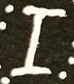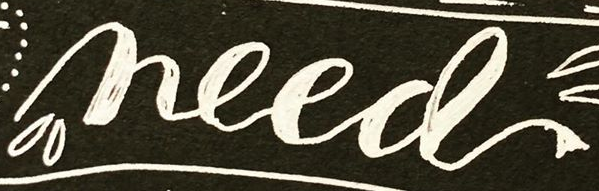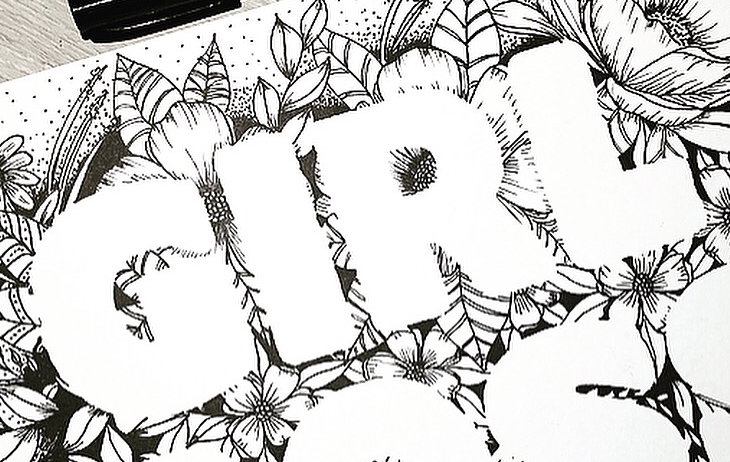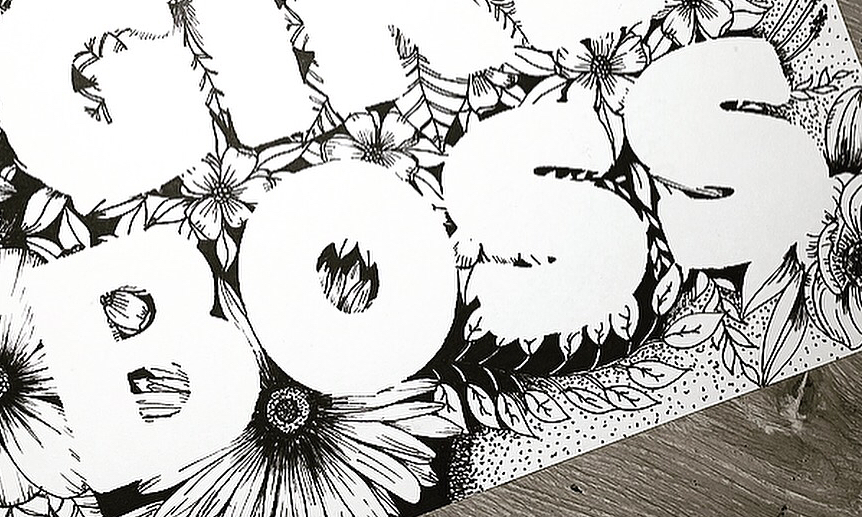What words are shown in these images in order, separated by a semicolon? I; need; GIRL; BOSS 